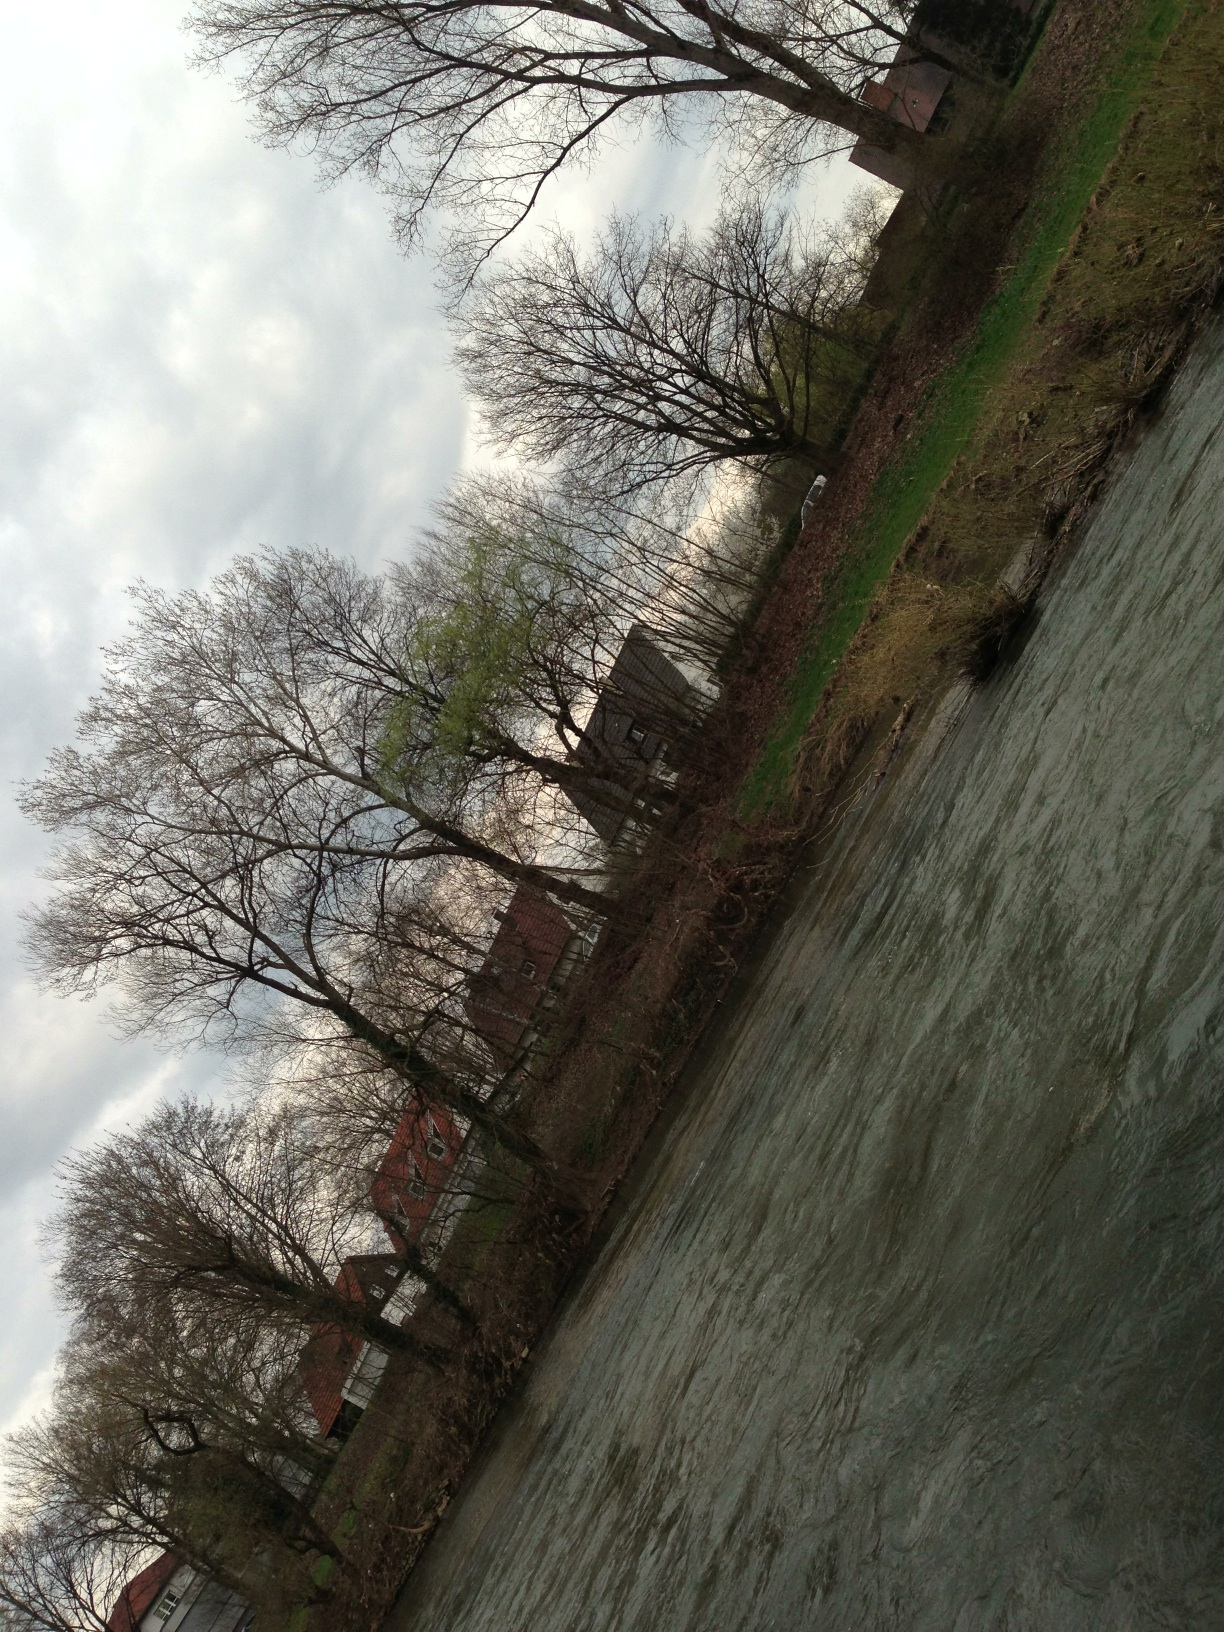Can you describe the buildings visible on the right side of the river? On the right, there are several buildings with steep roofs and a solid, brick construction, typical of a traditional architectural style for rural European villages. These houses are closely packed together, suggesting a small, closely-knit community. 